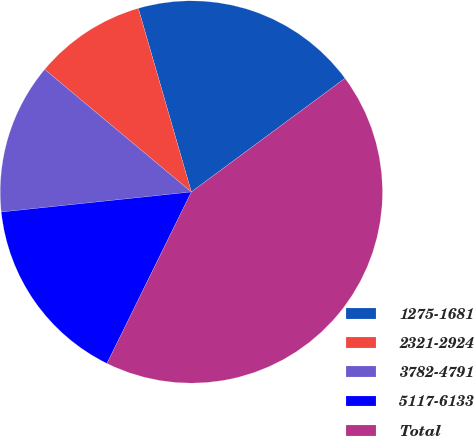<chart> <loc_0><loc_0><loc_500><loc_500><pie_chart><fcel>1275-1681<fcel>2321-2924<fcel>3782-4791<fcel>5117-6133<fcel>Total<nl><fcel>19.34%<fcel>9.45%<fcel>12.75%<fcel>16.05%<fcel>42.41%<nl></chart> 